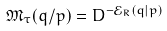Convert formula to latex. <formula><loc_0><loc_0><loc_500><loc_500>\mathfrak { M } _ { \tau } ( q / p ) = D ^ { - \mathcal { E } _ { R } ( q | p ) }</formula> 